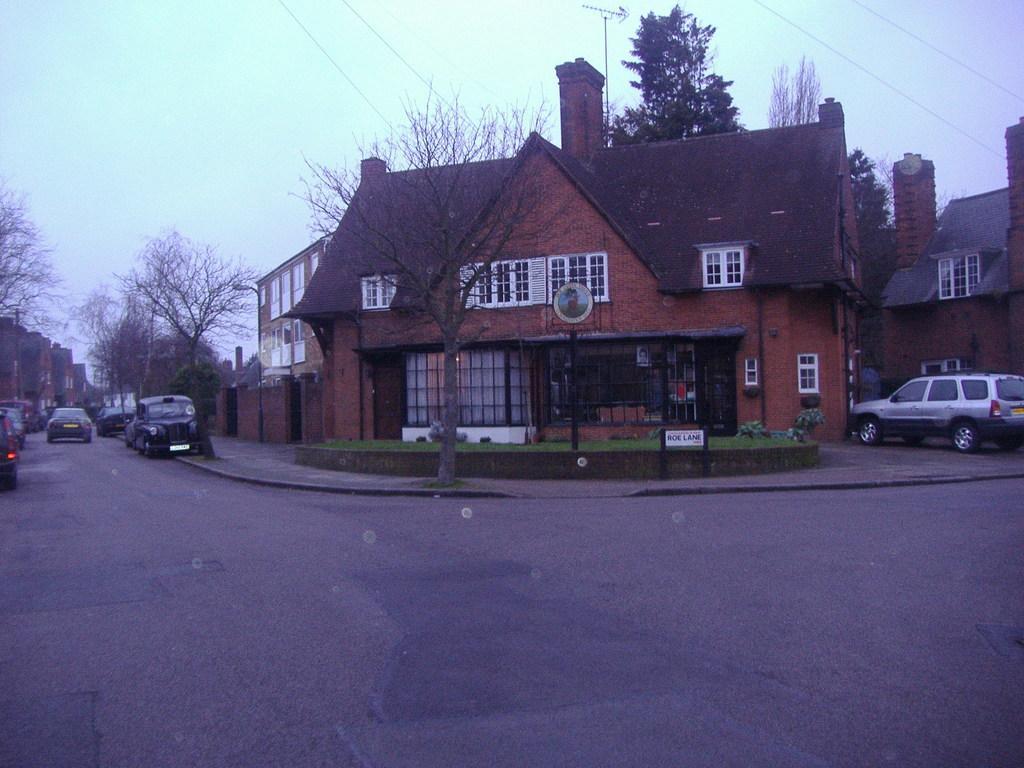Please provide a concise description of this image. In this image there are buildings and trees. At the bottom there are cars on the road. In the background there is sky and we can see wires. 